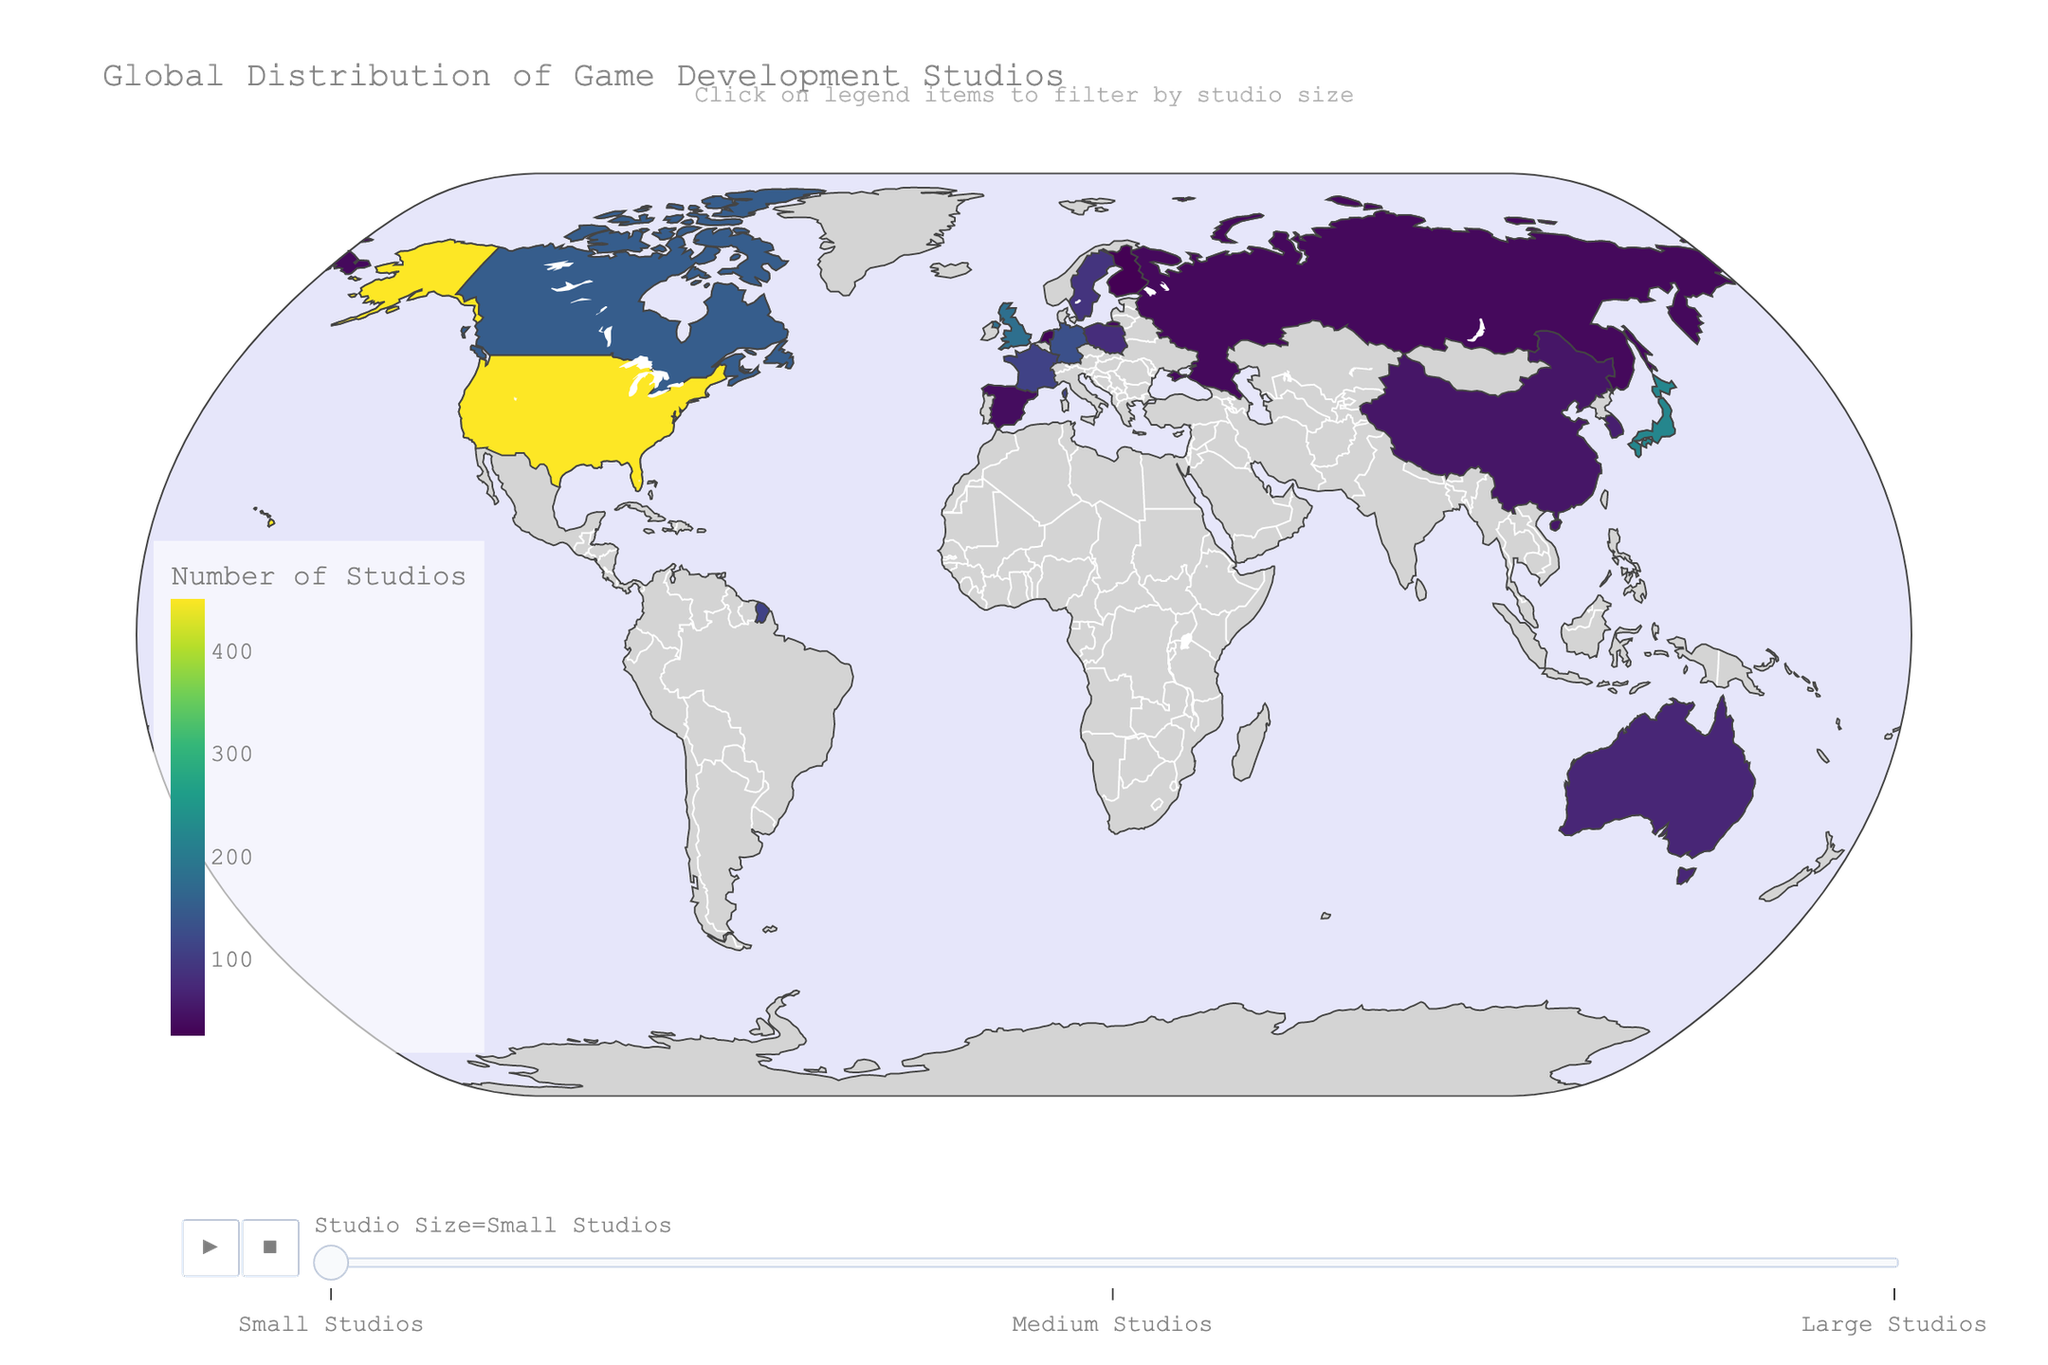what is the title of the figure? Look at the top of the figure where the title is located. The plot title usually describes the main content or purpose of the figure.
Answer: Global Distribution of Game Development Studios How many types of studio sizes are shown in the figure? Analyze the animation frames or legend to see the different categories of studio sizes displayed in the plot.
Answer: Three Which country has the most medium-sized studios? Examine the data or the color intensity corresponding to medium-sized studios for each country. Look for the country with the highest count.
Answer: United States How many small studios are there in France? Identify the animation frame for small studios and locate France. Read the value indicating the number of small studios.
Answer: 110 What is the total number of large studios in Japan and Germany combined? Locate the data for large studios in both Japan and Germany, then add the numbers together. Japan has 25 large studios, and Germany has 8 large studios, adding up to 33.
Answer: 33 Which two countries have the same number of large studios? Scan the figure for the large studio category, comparing countries to find two with identical counts. Finland and China both have 1 large studio.
Answer: Finland and China Compare the number of medium-sized studios in the United States and Canada. Which country has more, and by how many? Locate both countries in the medium studio animation frame and calculate the difference between their counts. The United States has 180 medium studios, and Canada has 60, so the US has 120 more.
Answer: United States, 120 more What is the average number of small studios in Australia, South Korea, and China? Identify the counts for small studios in each of these countries (Australia: 70, South Korea: 60, China: 50), sum them up (70 + 60 + 50 = 180), and divide by 3 to find the average. The average is 180 / 3 = 60.
Answer: 60 In which country is the number of large studios significantly lower compared to the number of small studios? Compare large and small studio counts for each country and identify where there's a substantial difference. The United States has 450 small studios but only 45 large studios, indicating a significant difference.
Answer: United States 